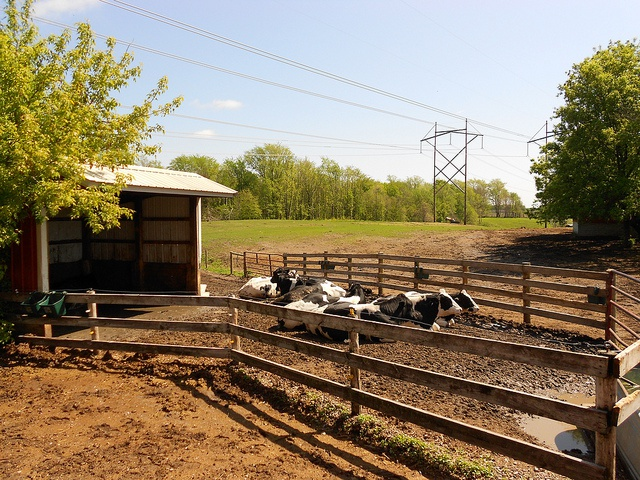Describe the objects in this image and their specific colors. I can see cow in lavender, black, maroon, and gray tones, cow in lavender, ivory, maroon, and black tones, cow in lavender, black, ivory, maroon, and gray tones, cow in lavender, black, gray, and maroon tones, and cow in lavender, ivory, gray, brown, and maroon tones in this image. 